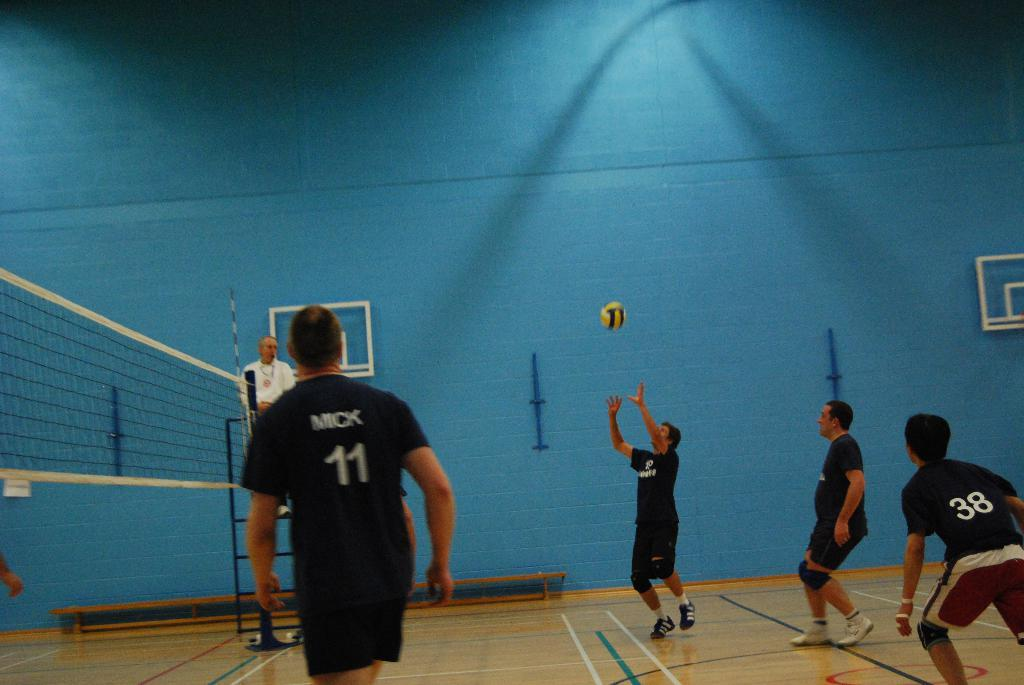<image>
Present a compact description of the photo's key features. Player number 11 called Mick watches as his teammate throws the ball in the air 